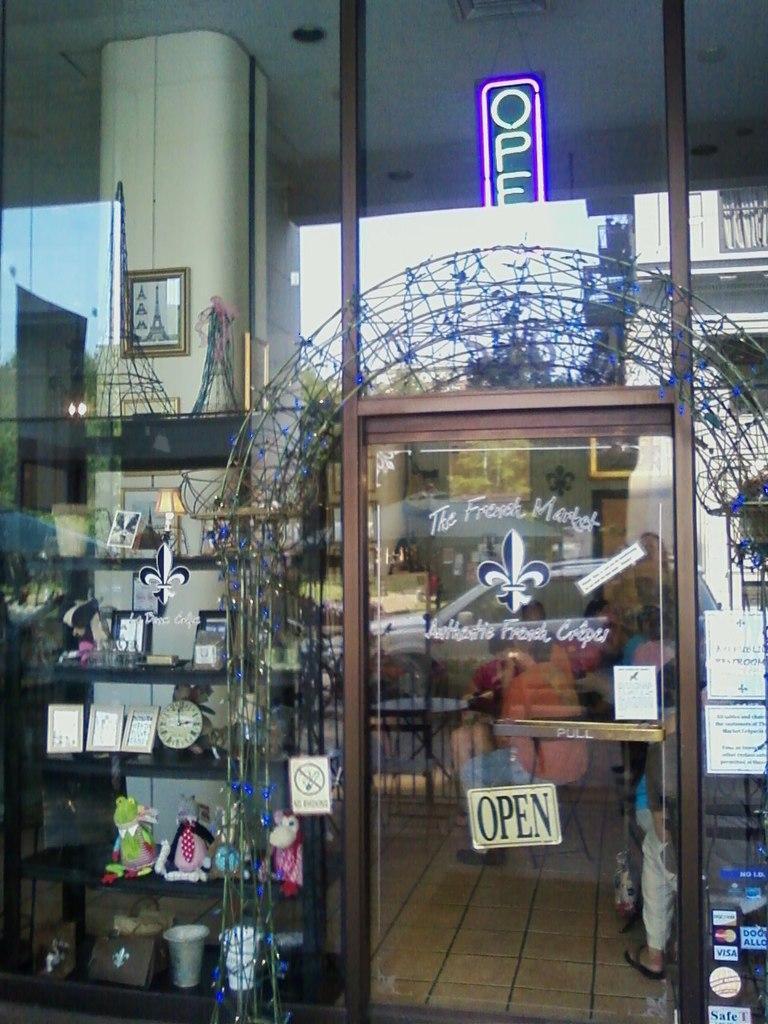In one or two sentences, can you explain what this image depicts? In this image in the front there is a door. Behind the door there are persons sitting. There is frame on the wall and on the shelfs there are frames, there are clocks, toys, which are on the left side, behind the glass in the shelves and on the door there is some text written on it which is in the center. On the top of the door, there is a text written on it. And there is a reflection of the building on the mirror. 